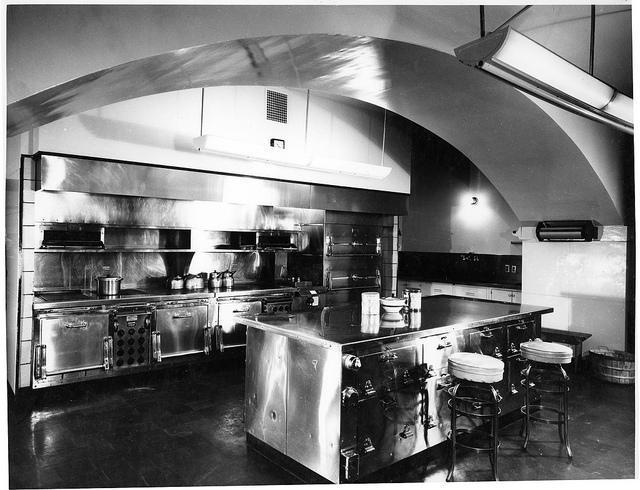How many chairs are in the photo?
Give a very brief answer. 2. How many ovens are in the picture?
Give a very brief answer. 3. How many trains are there?
Give a very brief answer. 0. 